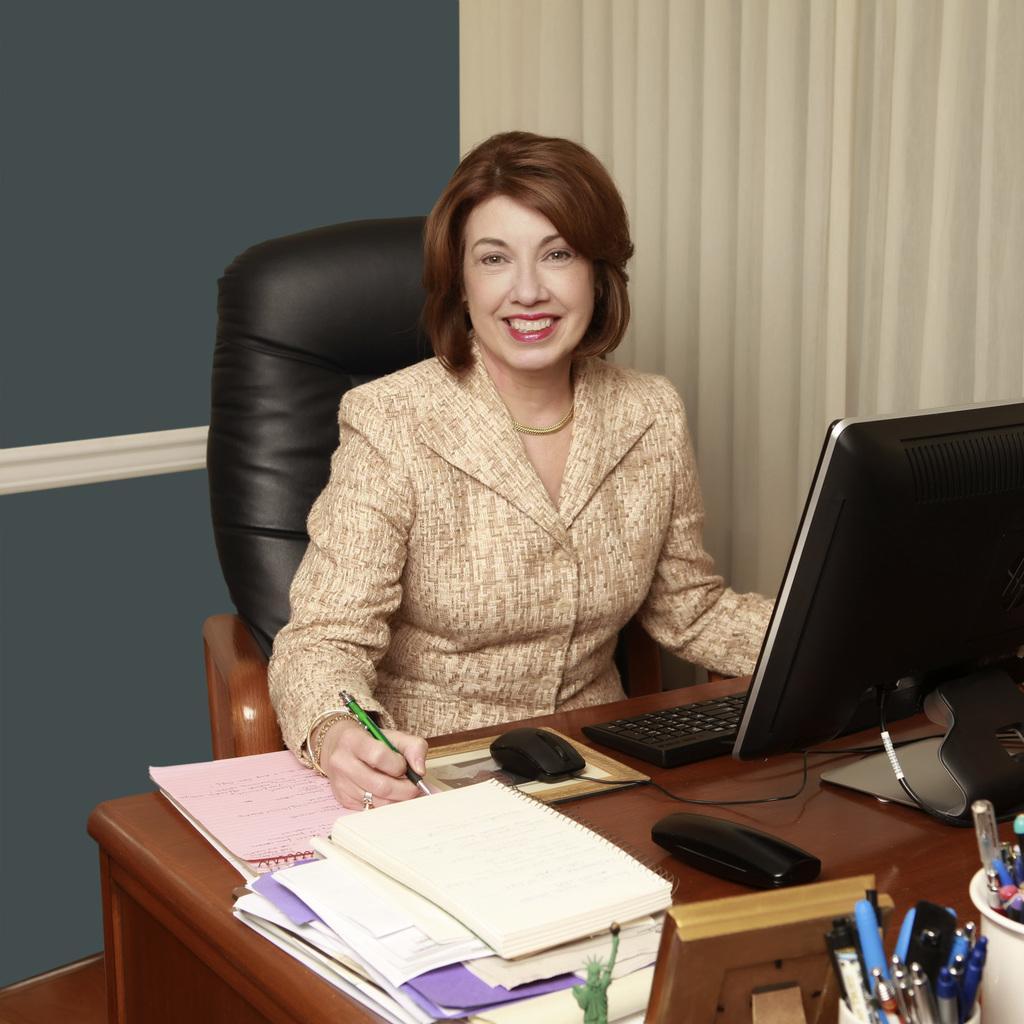Please provide a concise description of this image. In this image we can see a woman sitting on the chair and holding a pen, and on the table there is a system, keyboard, mouse, mouse pad, a box, papers, few pens in the pen stand, a photo frame and few objects and there is a curtain on the right side and a wall in the background. 